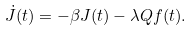<formula> <loc_0><loc_0><loc_500><loc_500>\dot { J } ( t ) = - \beta J ( t ) - \lambda Q f ( t ) .</formula> 